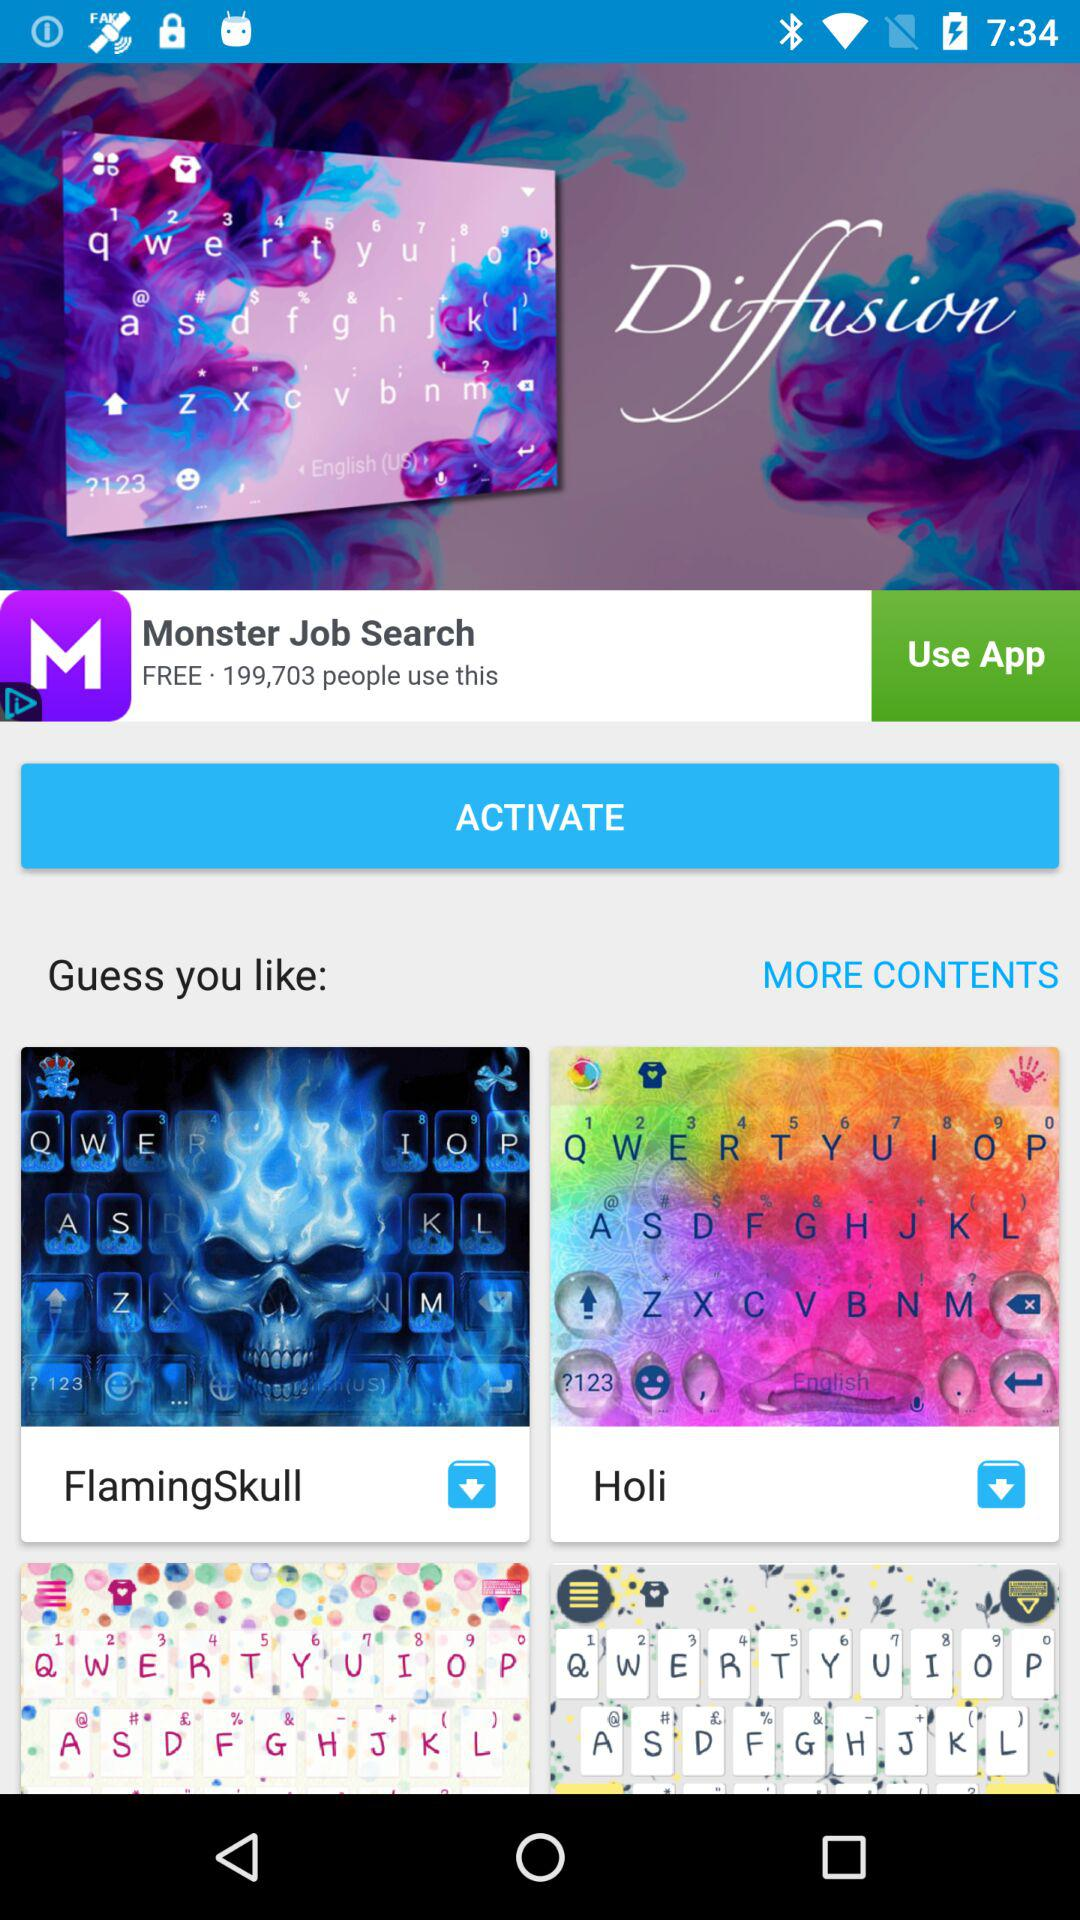What is the number of people using Monster Job Search? The number of people using Monster Job Search is 199,703. 